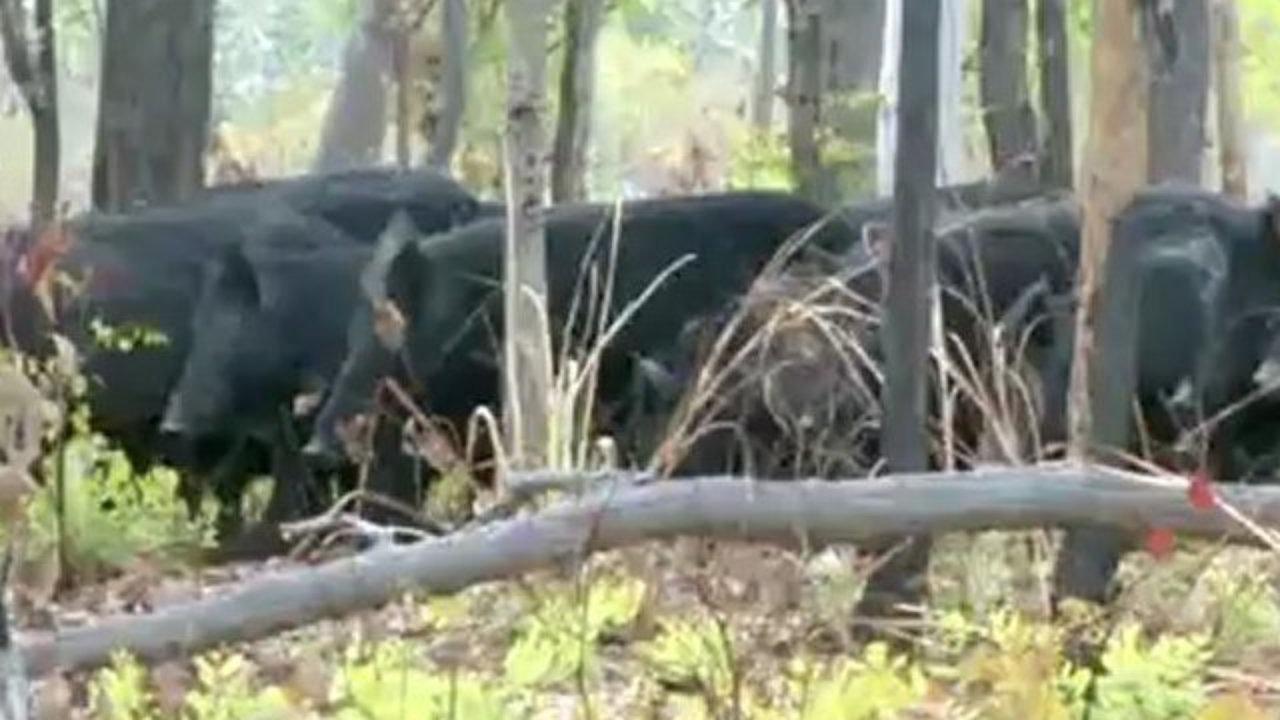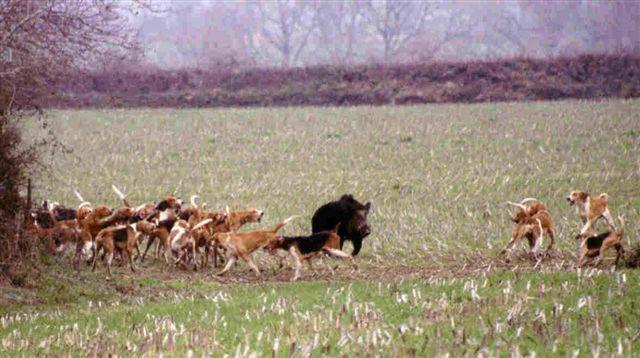The first image is the image on the left, the second image is the image on the right. Considering the images on both sides, is "There are at least four black boars outside." valid? Answer yes or no. Yes. 